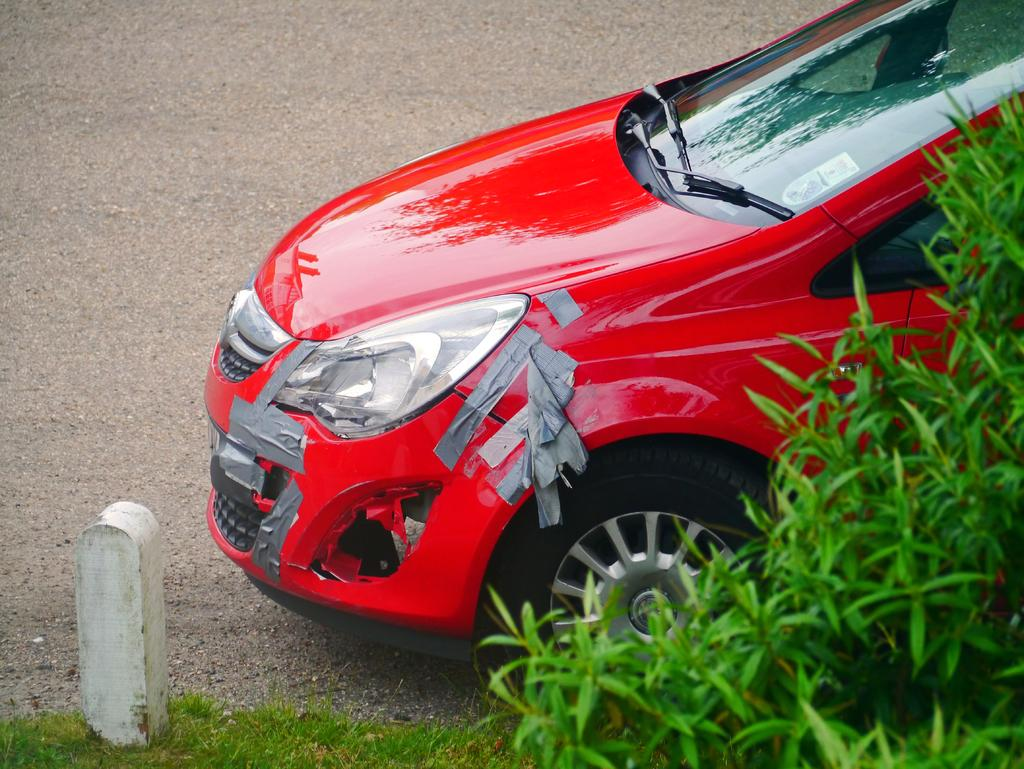What color is the vehicle in the image? The vehicle in the image is red. What can be seen on the vehicle? The vehicle has tapes on it. What is visible beneath the vehicle? The ground is visible in the image. What is the tall, vertical object in the image? There is a pole in the image. What type of vegetation is present in the image? There is grass in the image, and plants are on the right side of the image. What type of underwear is hanging on the pole in the image? There is no underwear present in the image; the pole is not associated with any clothing items. 